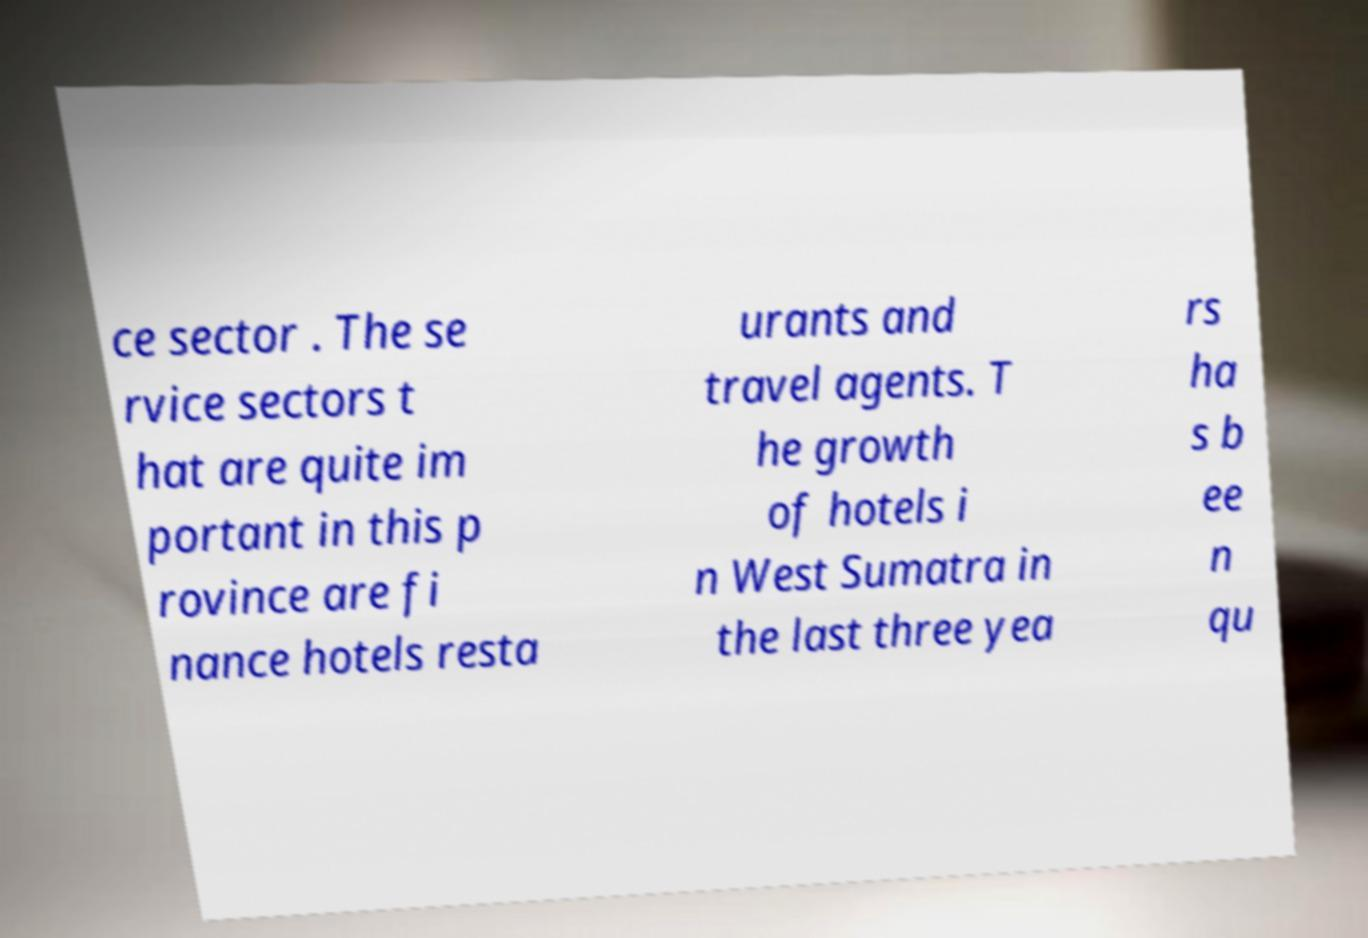Can you accurately transcribe the text from the provided image for me? ce sector . The se rvice sectors t hat are quite im portant in this p rovince are fi nance hotels resta urants and travel agents. T he growth of hotels i n West Sumatra in the last three yea rs ha s b ee n qu 